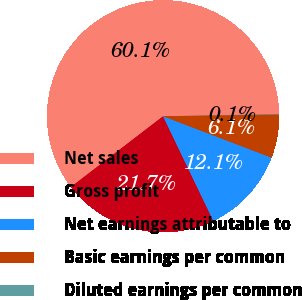Convert chart. <chart><loc_0><loc_0><loc_500><loc_500><pie_chart><fcel>Net sales<fcel>Gross profit<fcel>Net earnings attributable to<fcel>Basic earnings per common<fcel>Diluted earnings per common<nl><fcel>60.11%<fcel>21.71%<fcel>12.07%<fcel>6.06%<fcel>0.06%<nl></chart> 